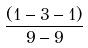Convert formula to latex. <formula><loc_0><loc_0><loc_500><loc_500>\frac { ( 1 - 3 - 1 ) } { 9 - 9 }</formula> 